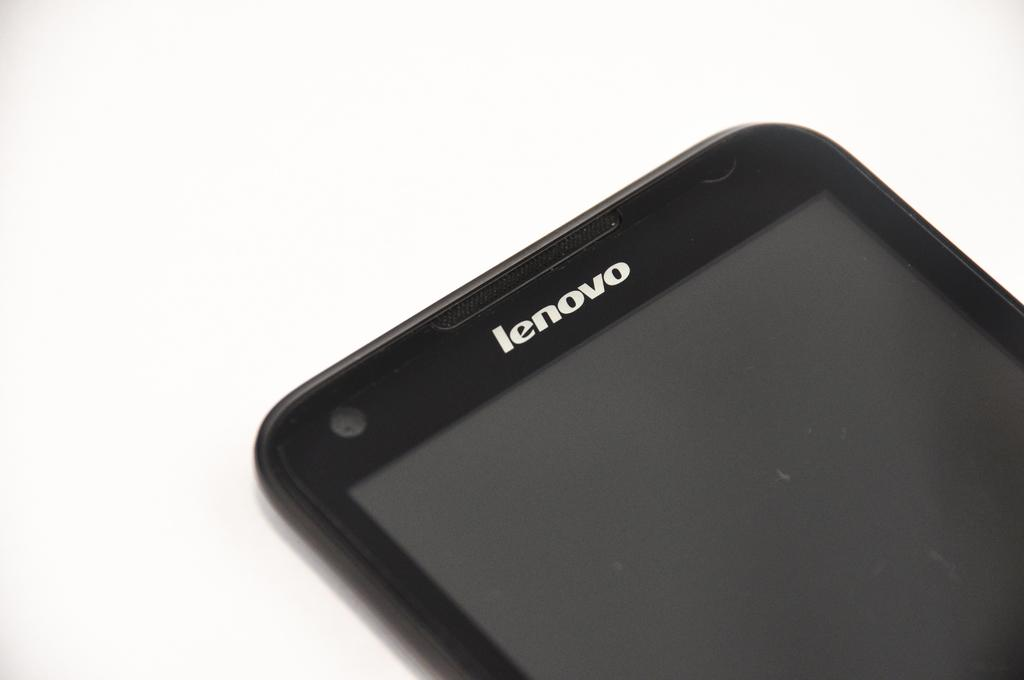Provide a one-sentence caption for the provided image. The front of a Lenovo phone that is currently off. 